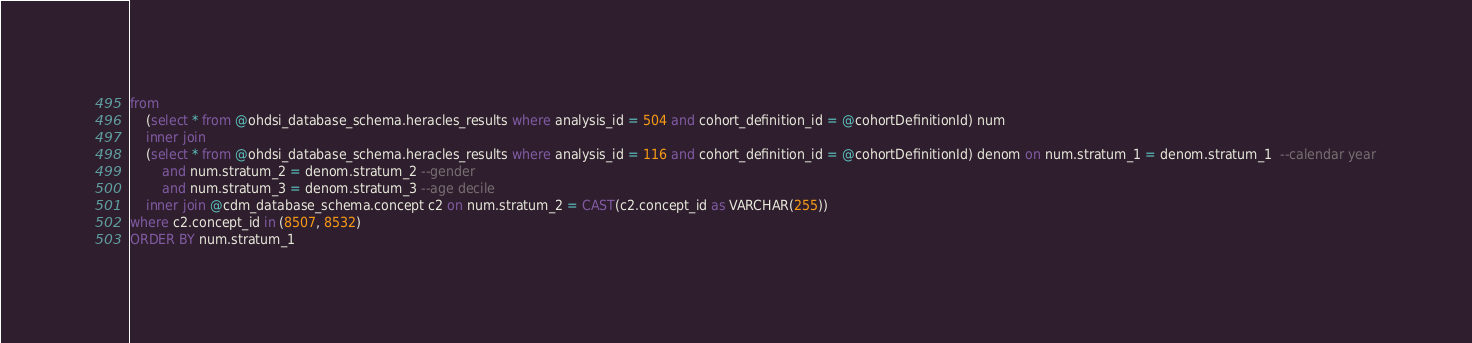Convert code to text. <code><loc_0><loc_0><loc_500><loc_500><_SQL_>from 
	(select * from @ohdsi_database_schema.heracles_results where analysis_id = 504 and cohort_definition_id = @cohortDefinitionId) num
	inner join
	(select * from @ohdsi_database_schema.heracles_results where analysis_id = 116 and cohort_definition_id = @cohortDefinitionId) denom on num.stratum_1 = denom.stratum_1  --calendar year
		and num.stratum_2 = denom.stratum_2 --gender
		and num.stratum_3 = denom.stratum_3 --age decile
	inner join @cdm_database_schema.concept c2 on num.stratum_2 = CAST(c2.concept_id as VARCHAR(255))
where c2.concept_id in (8507, 8532)
ORDER BY num.stratum_1
</code> 